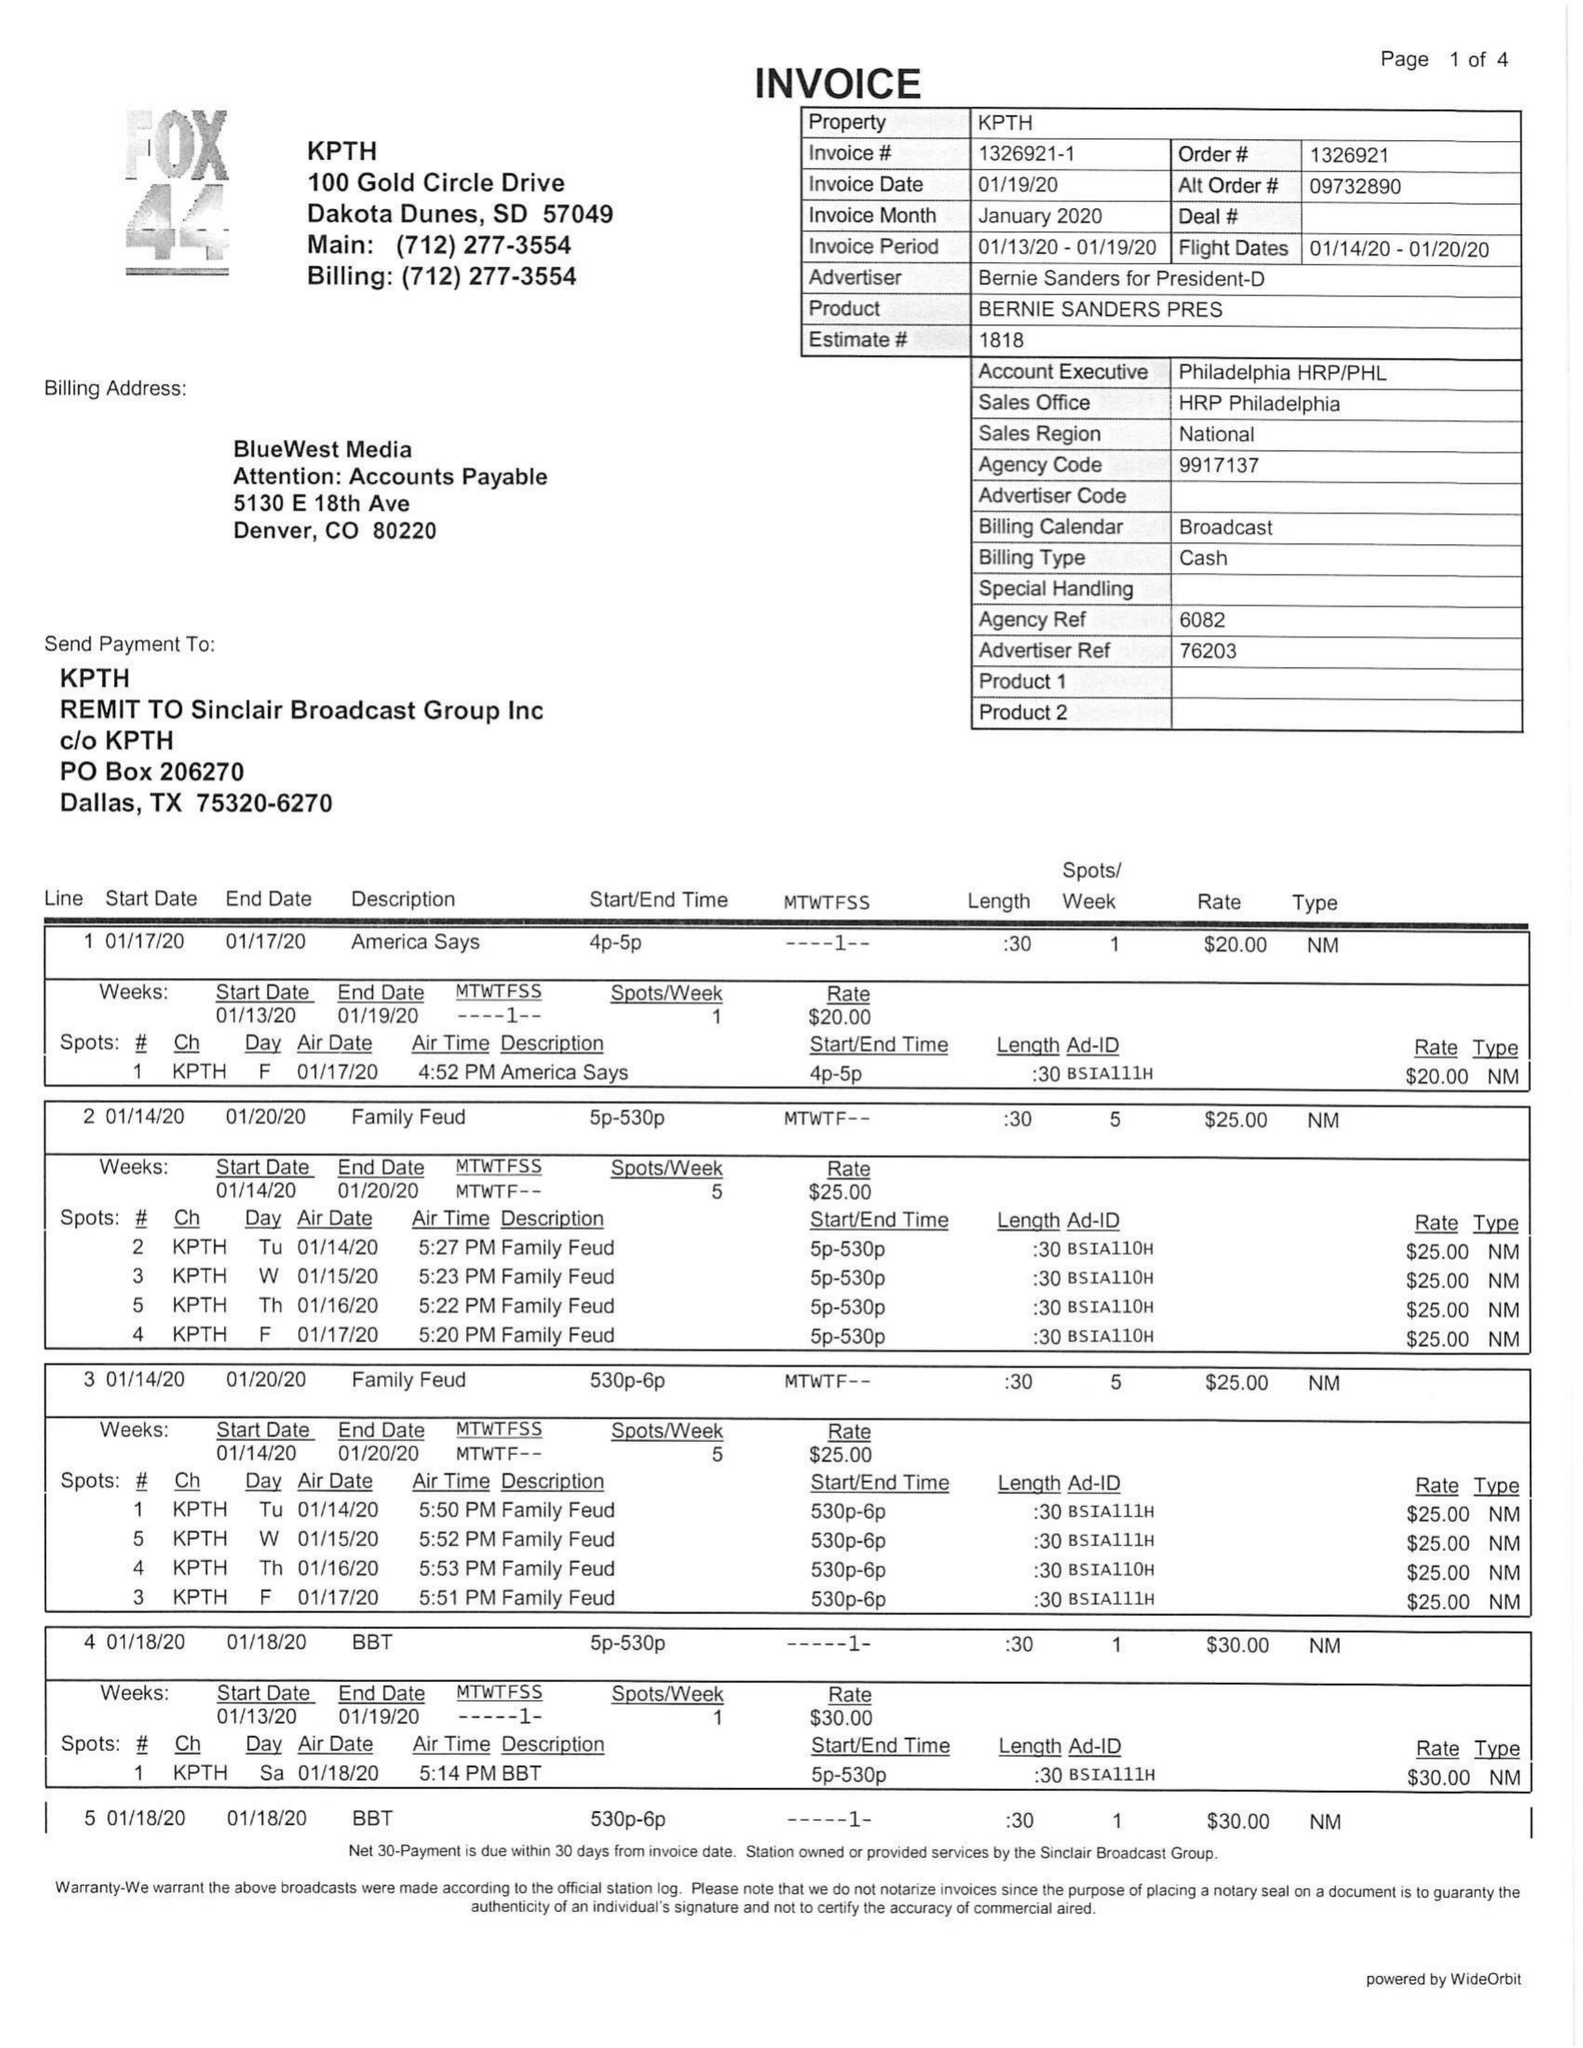What is the value for the flight_from?
Answer the question using a single word or phrase. 01/14/20 